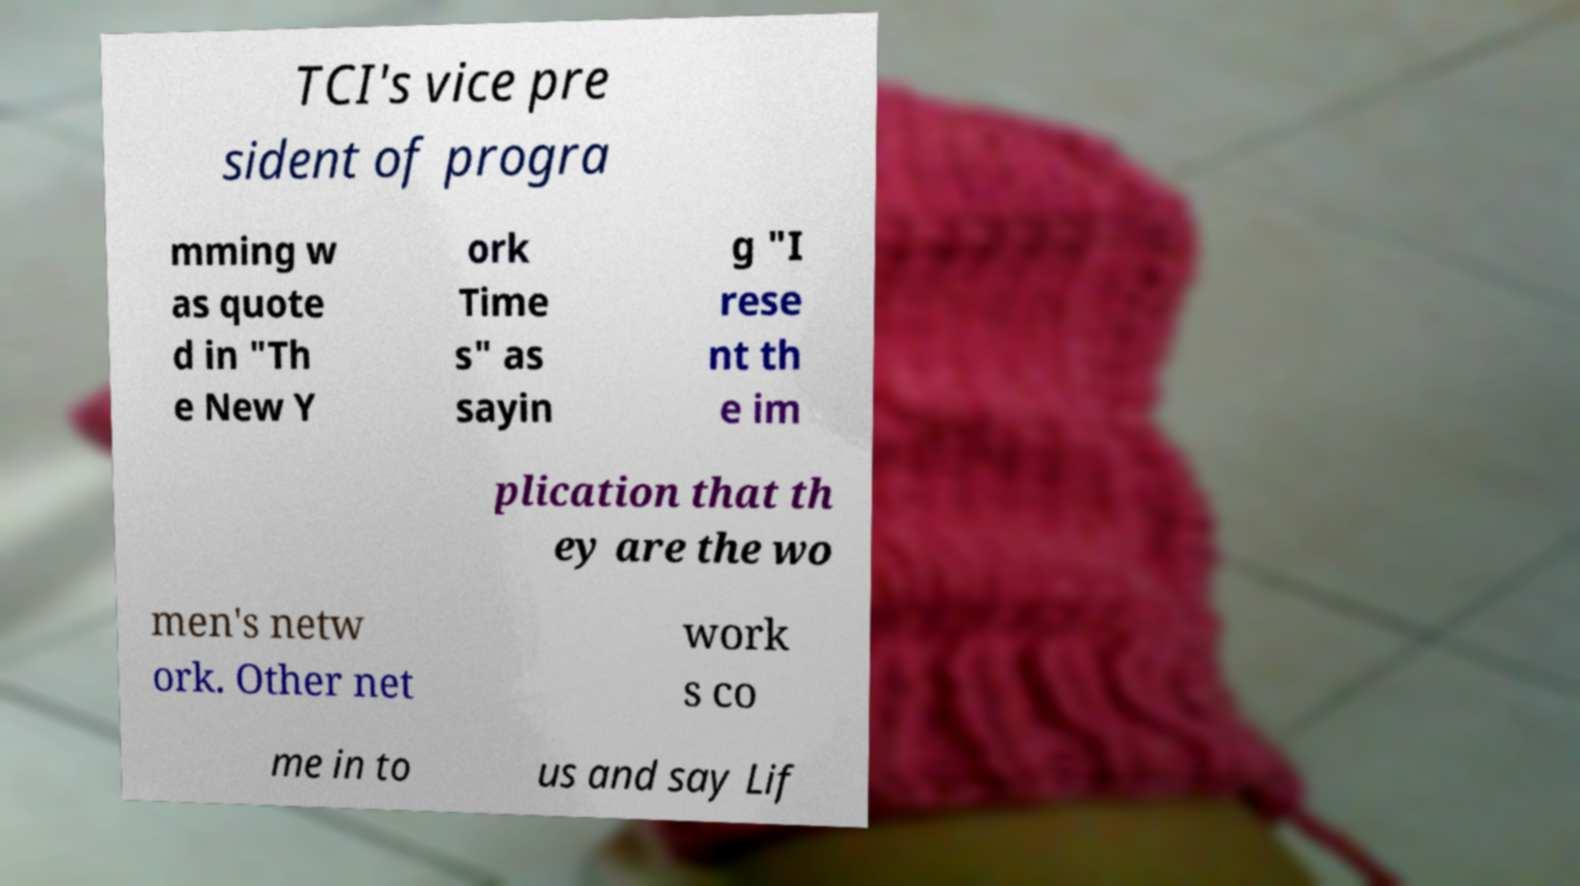For documentation purposes, I need the text within this image transcribed. Could you provide that? TCI's vice pre sident of progra mming w as quote d in "Th e New Y ork Time s" as sayin g "I rese nt th e im plication that th ey are the wo men's netw ork. Other net work s co me in to us and say Lif 